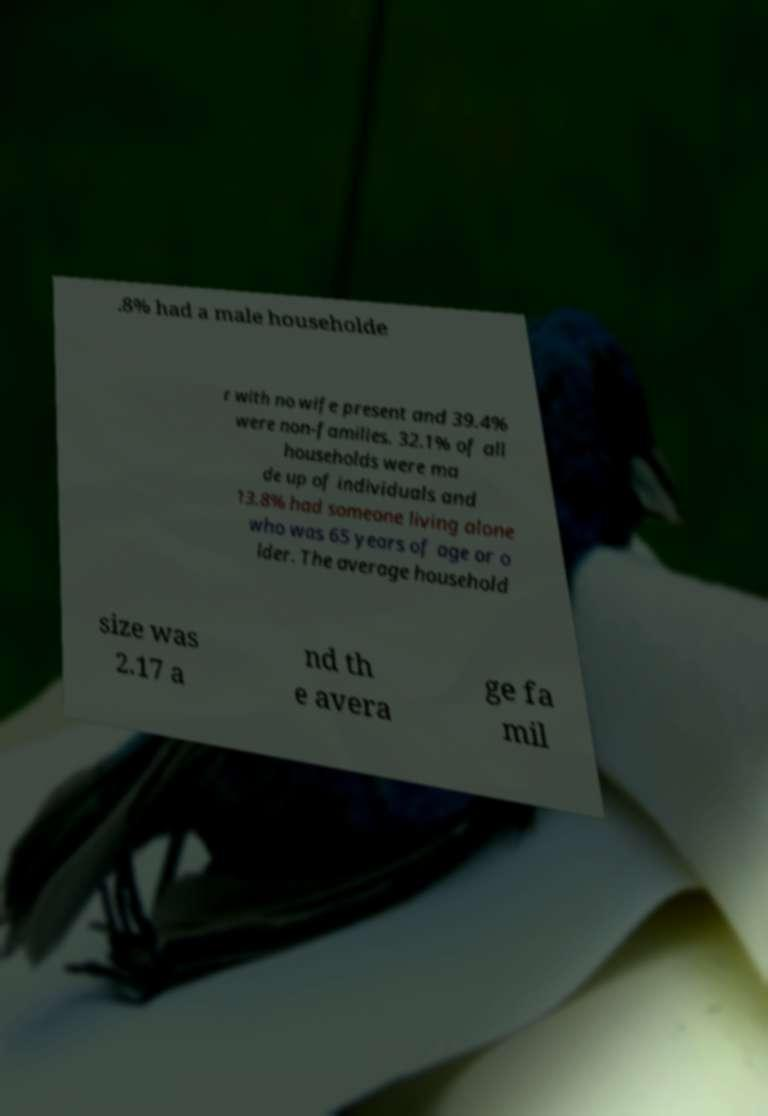There's text embedded in this image that I need extracted. Can you transcribe it verbatim? .8% had a male householde r with no wife present and 39.4% were non-families. 32.1% of all households were ma de up of individuals and 13.8% had someone living alone who was 65 years of age or o lder. The average household size was 2.17 a nd th e avera ge fa mil 